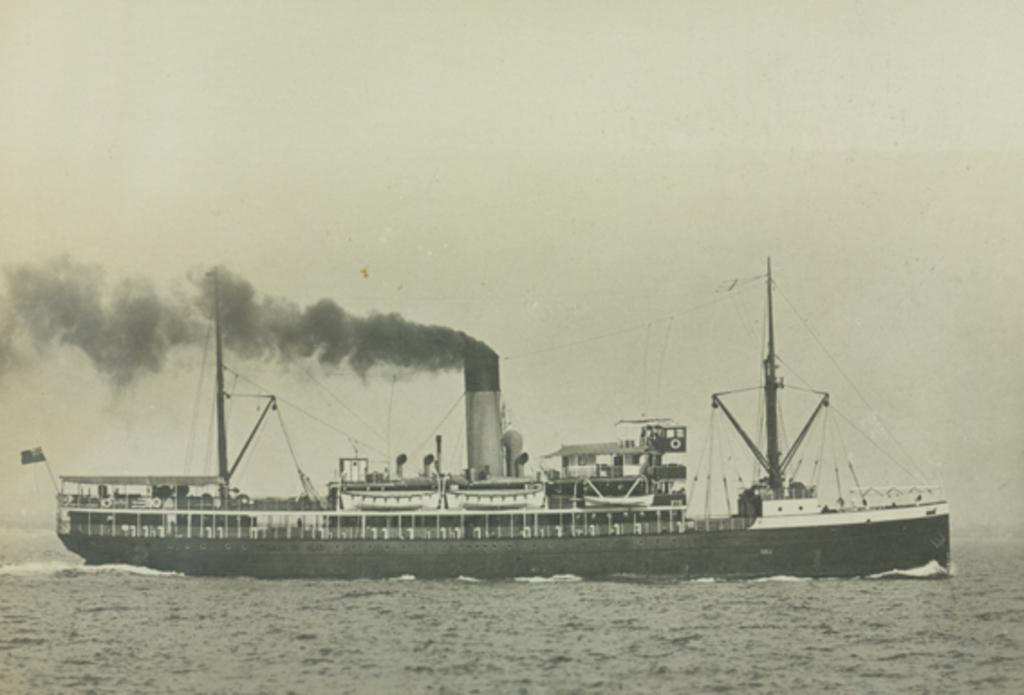What is the main subject in the center of the image? There is a ship in the center of the image. What type of environment is depicted in the image? The image shows a ship on water, suggesting a maritime setting. Where is the garden located in the image? There is no garden present in the image. What type of animal can be seen flying near the ship in the image? There is no animal, such as a bat, visible near the ship in the image. 